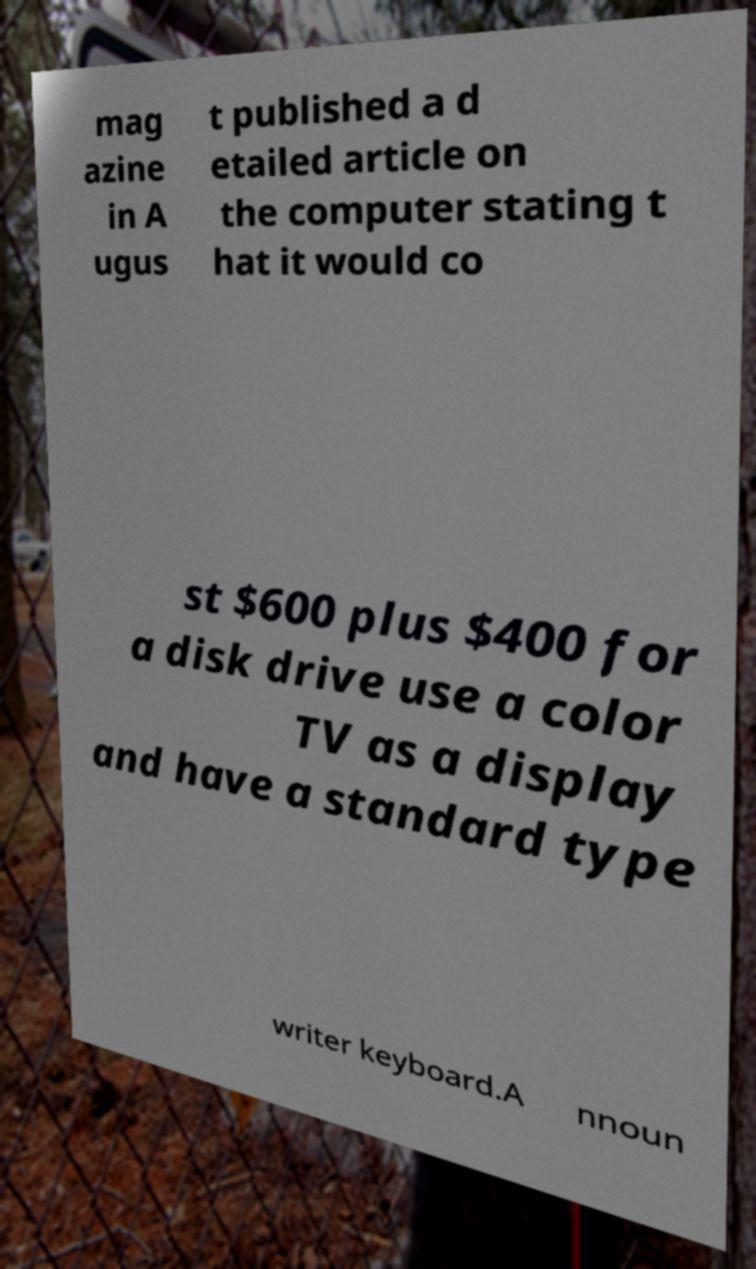Please identify and transcribe the text found in this image. mag azine in A ugus t published a d etailed article on the computer stating t hat it would co st $600 plus $400 for a disk drive use a color TV as a display and have a standard type writer keyboard.A nnoun 